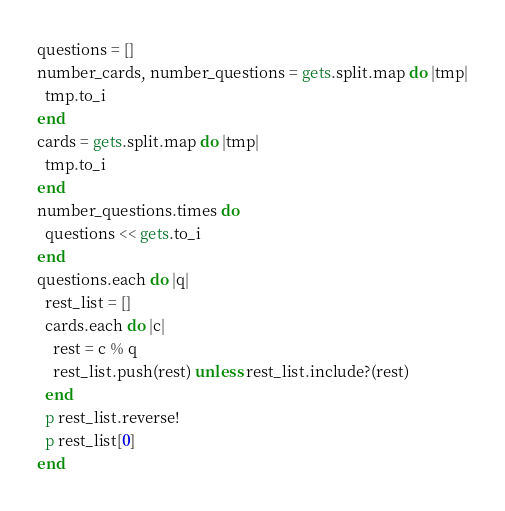<code> <loc_0><loc_0><loc_500><loc_500><_Ruby_>questions = []
number_cards, number_questions = gets.split.map do |tmp|
  tmp.to_i
end
cards = gets.split.map do |tmp|
  tmp.to_i
end
number_questions.times do
  questions << gets.to_i
end
questions.each do |q|
  rest_list = []
  cards.each do |c|
    rest = c % q
    rest_list.push(rest) unless rest_list.include?(rest)
  end
  p rest_list.reverse!
  p rest_list[0]
end</code> 